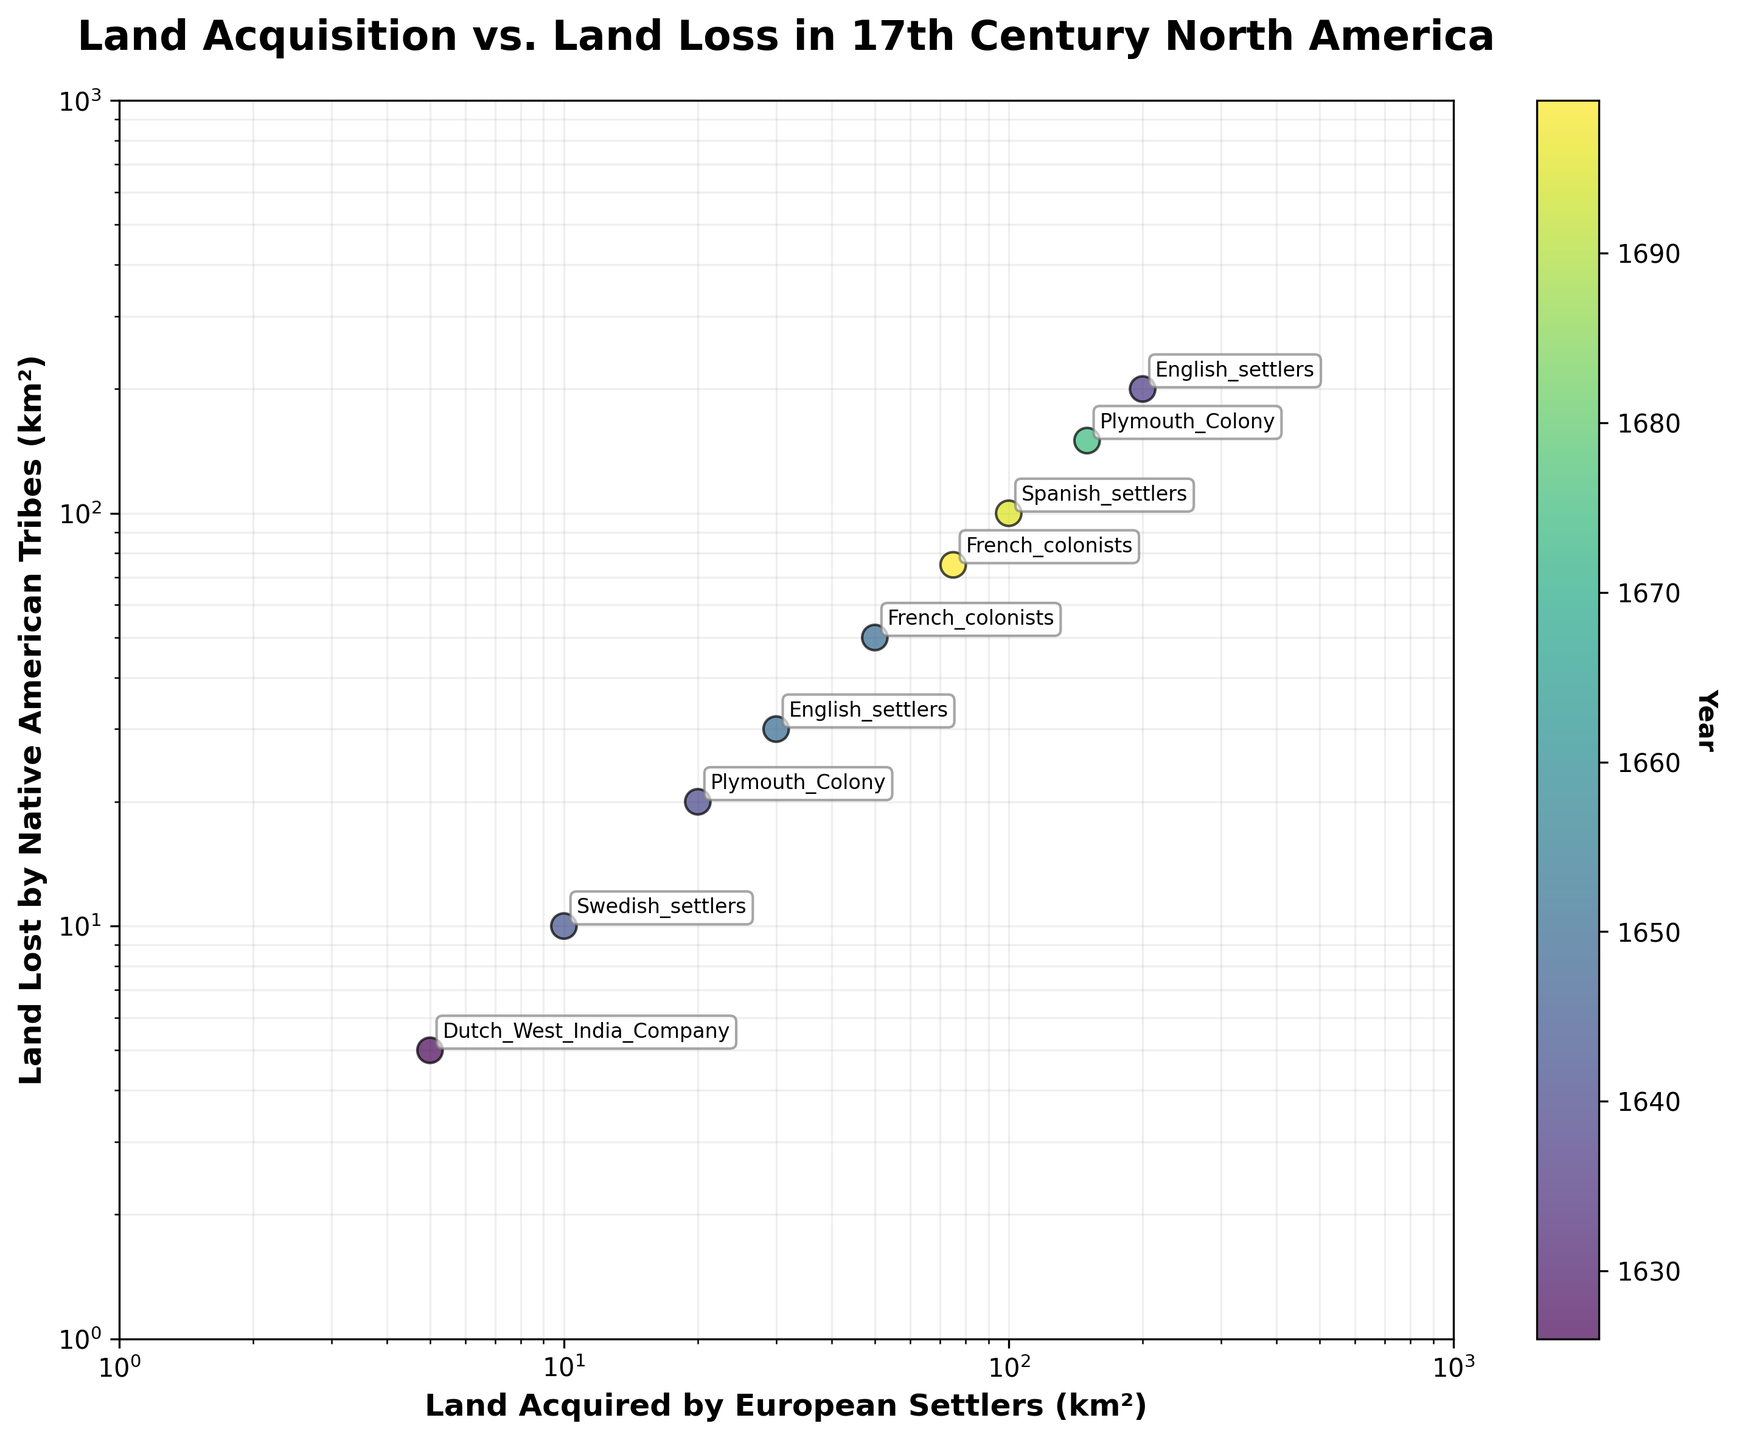How many European settler groups are documented in the figure? Counting the number of unique annotations representing European settler groups in the scatter plot, we find the following: Dutch West India Company, Plymouth Colony, English settlers, French colonists, Swedish settlers, Spanish settlers. Hence, there are six distinct European settler groups.
Answer: 6 Which European settler group acquired the most land in one event? Observing the scatter plot, the data point for the English settlers (with a logarithmic value very close to 200 km²) stands out as the largest acquisition in one event.
Answer: English settlers Which year saw the largest land acquisition recorded on the plot? The data point representing the English settlers with the land acquisition of 200 km² corresponds to the year 1637.
Answer: 1637 Identify the European settler group and Native American tribe associated with the smallest land transaction recorded? On the scatter plot, the smallest transaction (both land loss and acquisition close to 5 km²) is associated with the Dutch West India Company and the Lenape tribe in 1626.
Answer: Dutch West India Company and Lenape Which European settler group made land acquisitions in 1650, and what were the acquired amounts? In the scatter plot, two data points from 1650 correspond to the French colonists acquiring from the Huron tribe (50 km²) and the English settlers from the Narragansett tribe (30 km²).
Answer: French colonists (50 km²) and English settlers (30 km²) What is the relationship trend between land acquired by European settlers and land lost by Native American tribes? The scatter plot shows a one-to-one correspondence between land acquired by European settlers and land lost by Native American tribes, indicating a direct relationship, which is linear on the log-log scale, implying proportionality.
Answer: Proportional Which group had land transactions in the year 1699 and what was the amount? Looking at the scatter plot's corresponding year color and annotation, the French colonists had transactions totaling 75 km² in the year 1699 with the Illinois Confederation.
Answer: French colonists, 75 km² Considering 1675, which groups were involved in land transactions and what was the land amount transferred? The scatter plot shows that in the year 1675, the Plymouth Colony acquired 150 km² from the Narragansett tribe.
Answer: Plymouth Colony, 150 km² 